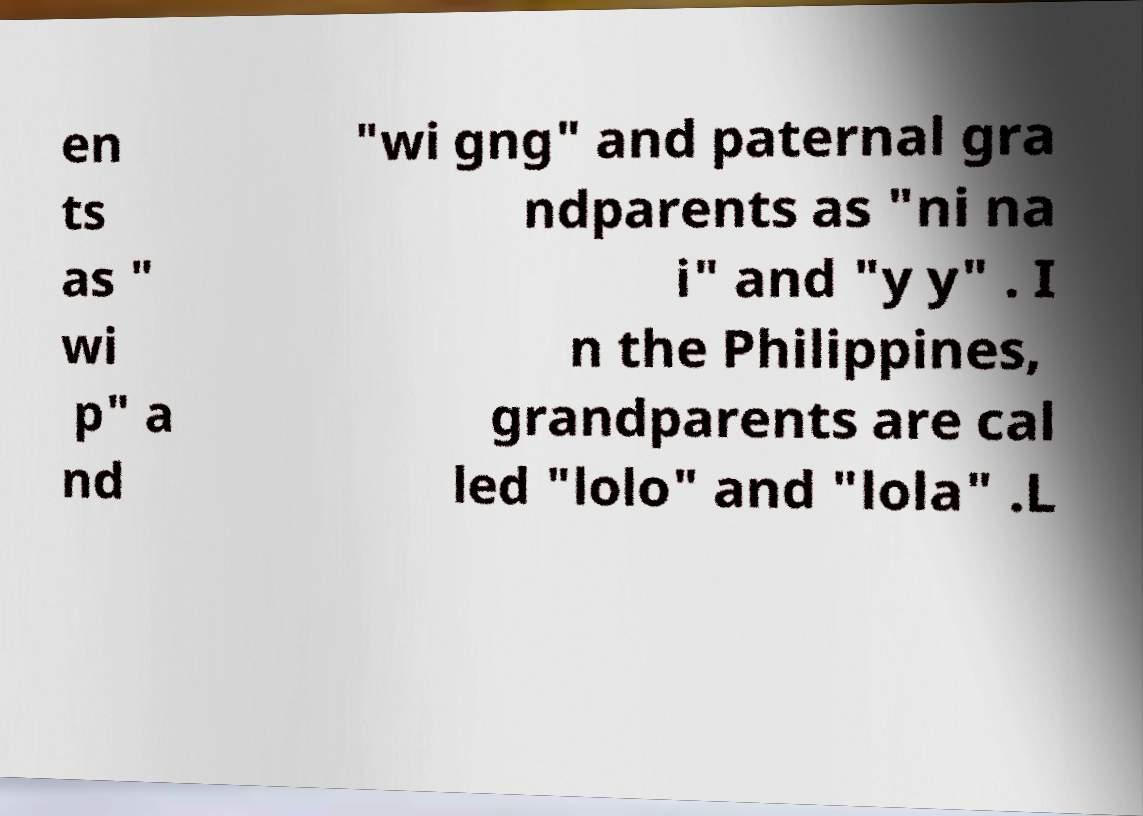Could you assist in decoding the text presented in this image and type it out clearly? en ts as " wi p" a nd "wi gng" and paternal gra ndparents as "ni na i" and "y y" . I n the Philippines, grandparents are cal led "lolo" and "lola" .L 